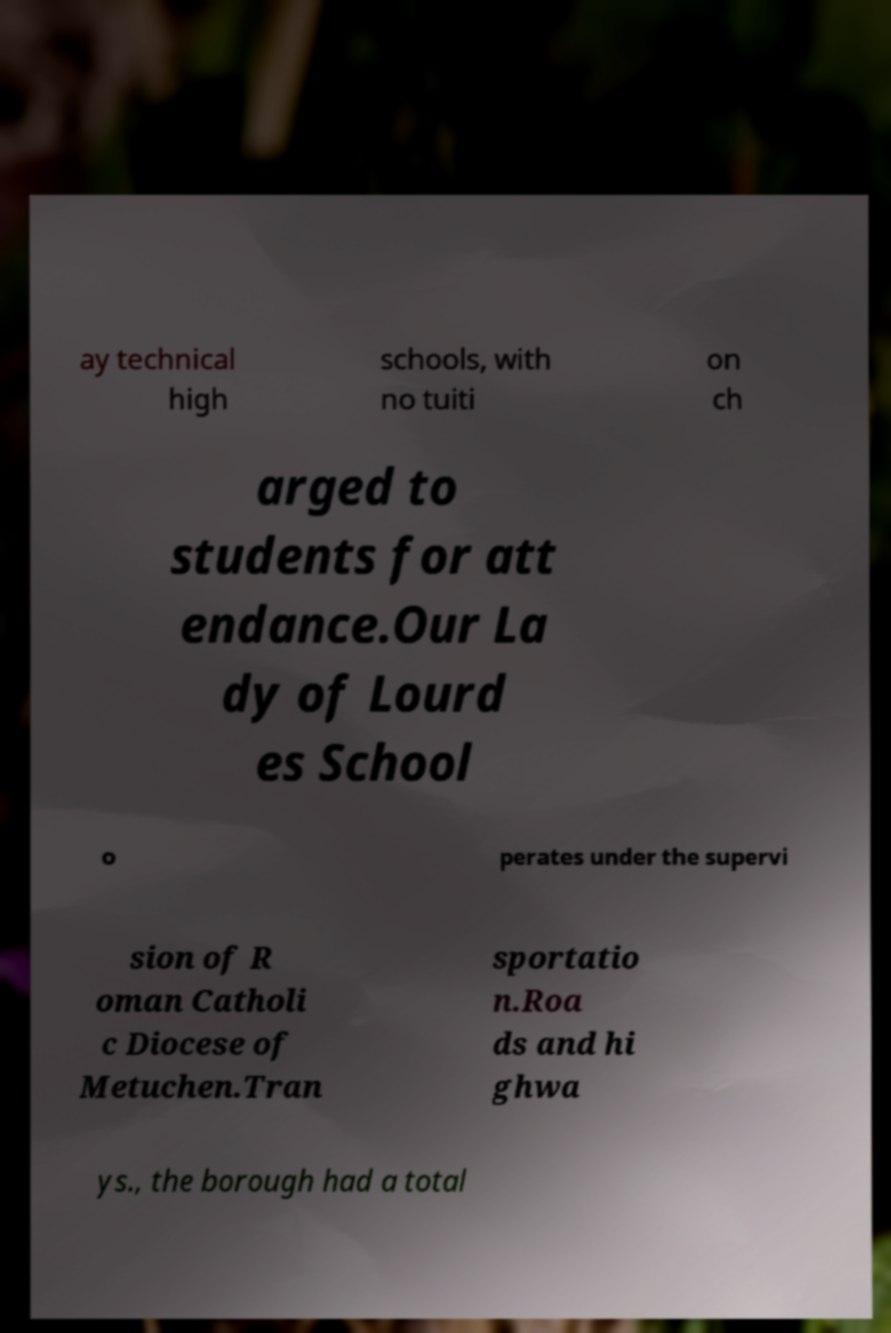Could you assist in decoding the text presented in this image and type it out clearly? ay technical high schools, with no tuiti on ch arged to students for att endance.Our La dy of Lourd es School o perates under the supervi sion of R oman Catholi c Diocese of Metuchen.Tran sportatio n.Roa ds and hi ghwa ys., the borough had a total 